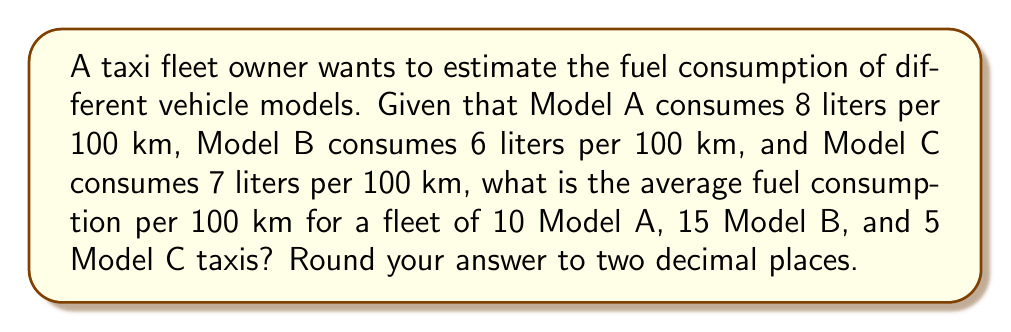Show me your answer to this math problem. To solve this problem, we need to follow these steps:

1. Calculate the total fuel consumption for each model:
   Model A: $10 \times 8 = 80$ liters
   Model B: $15 \times 6 = 90$ liters
   Model C: $5 \times 7 = 35$ liters

2. Calculate the total fuel consumption for all vehicles:
   $$ \text{Total consumption} = 80 + 90 + 35 = 205 \text{ liters} $$

3. Calculate the total number of vehicles:
   $$ \text{Total vehicles} = 10 + 15 + 5 = 30 $$

4. Calculate the average fuel consumption per 100 km:
   $$ \text{Average consumption} = \frac{\text{Total consumption}}{\text{Total vehicles}} $$
   $$ = \frac{205}{30} = 6.8333... \text{ liters per 100 km} $$

5. Round the result to two decimal places:
   $$ 6.83 \text{ liters per 100 km} $$
Answer: 6.83 liters per 100 km 